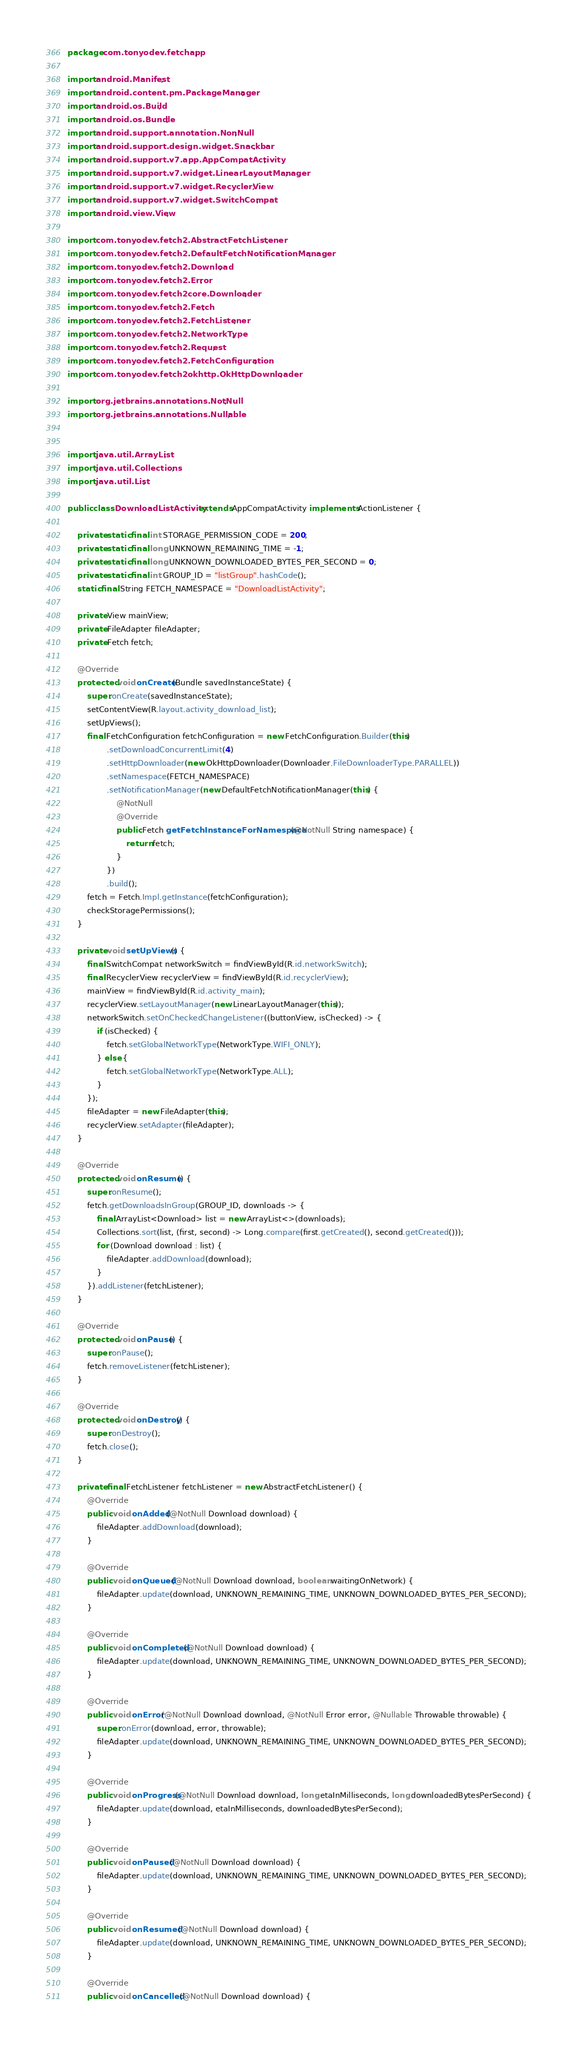Convert code to text. <code><loc_0><loc_0><loc_500><loc_500><_Java_>package com.tonyodev.fetchapp;

import android.Manifest;
import android.content.pm.PackageManager;
import android.os.Build;
import android.os.Bundle;
import android.support.annotation.NonNull;
import android.support.design.widget.Snackbar;
import android.support.v7.app.AppCompatActivity;
import android.support.v7.widget.LinearLayoutManager;
import android.support.v7.widget.RecyclerView;
import android.support.v7.widget.SwitchCompat;
import android.view.View;

import com.tonyodev.fetch2.AbstractFetchListener;
import com.tonyodev.fetch2.DefaultFetchNotificationManager;
import com.tonyodev.fetch2.Download;
import com.tonyodev.fetch2.Error;
import com.tonyodev.fetch2core.Downloader;
import com.tonyodev.fetch2.Fetch;
import com.tonyodev.fetch2.FetchListener;
import com.tonyodev.fetch2.NetworkType;
import com.tonyodev.fetch2.Request;
import com.tonyodev.fetch2.FetchConfiguration;
import com.tonyodev.fetch2okhttp.OkHttpDownloader;

import org.jetbrains.annotations.NotNull;
import org.jetbrains.annotations.Nullable;


import java.util.ArrayList;
import java.util.Collections;
import java.util.List;

public class DownloadListActivity extends AppCompatActivity implements ActionListener {

    private static final int STORAGE_PERMISSION_CODE = 200;
    private static final long UNKNOWN_REMAINING_TIME = -1;
    private static final long UNKNOWN_DOWNLOADED_BYTES_PER_SECOND = 0;
    private static final int GROUP_ID = "listGroup".hashCode();
    static final String FETCH_NAMESPACE = "DownloadListActivity";

    private View mainView;
    private FileAdapter fileAdapter;
    private Fetch fetch;

    @Override
    protected void onCreate(Bundle savedInstanceState) {
        super.onCreate(savedInstanceState);
        setContentView(R.layout.activity_download_list);
        setUpViews();
        final FetchConfiguration fetchConfiguration = new FetchConfiguration.Builder(this)
                .setDownloadConcurrentLimit(4)
                .setHttpDownloader(new OkHttpDownloader(Downloader.FileDownloaderType.PARALLEL))
                .setNamespace(FETCH_NAMESPACE)
                .setNotificationManager(new DefaultFetchNotificationManager(this) {
                    @NotNull
                    @Override
                    public Fetch getFetchInstanceForNamespace(@NotNull String namespace) {
                        return fetch;
                    }
                })
                .build();
        fetch = Fetch.Impl.getInstance(fetchConfiguration);
        checkStoragePermissions();
    }

    private void setUpViews() {
        final SwitchCompat networkSwitch = findViewById(R.id.networkSwitch);
        final RecyclerView recyclerView = findViewById(R.id.recyclerView);
        mainView = findViewById(R.id.activity_main);
        recyclerView.setLayoutManager(new LinearLayoutManager(this));
        networkSwitch.setOnCheckedChangeListener((buttonView, isChecked) -> {
            if (isChecked) {
                fetch.setGlobalNetworkType(NetworkType.WIFI_ONLY);
            } else {
                fetch.setGlobalNetworkType(NetworkType.ALL);
            }
        });
        fileAdapter = new FileAdapter(this);
        recyclerView.setAdapter(fileAdapter);
    }

    @Override
    protected void onResume() {
        super.onResume();
        fetch.getDownloadsInGroup(GROUP_ID, downloads -> {
            final ArrayList<Download> list = new ArrayList<>(downloads);
            Collections.sort(list, (first, second) -> Long.compare(first.getCreated(), second.getCreated()));
            for (Download download : list) {
                fileAdapter.addDownload(download);
            }
        }).addListener(fetchListener);
    }

    @Override
    protected void onPause() {
        super.onPause();
        fetch.removeListener(fetchListener);
    }

    @Override
    protected void onDestroy() {
        super.onDestroy();
        fetch.close();
    }

    private final FetchListener fetchListener = new AbstractFetchListener() {
        @Override
        public void onAdded(@NotNull Download download) {
            fileAdapter.addDownload(download);
        }

        @Override
        public void onQueued(@NotNull Download download, boolean waitingOnNetwork) {
            fileAdapter.update(download, UNKNOWN_REMAINING_TIME, UNKNOWN_DOWNLOADED_BYTES_PER_SECOND);
        }

        @Override
        public void onCompleted(@NotNull Download download) {
            fileAdapter.update(download, UNKNOWN_REMAINING_TIME, UNKNOWN_DOWNLOADED_BYTES_PER_SECOND);
        }

        @Override
        public void onError(@NotNull Download download, @NotNull Error error, @Nullable Throwable throwable) {
            super.onError(download, error, throwable);
            fileAdapter.update(download, UNKNOWN_REMAINING_TIME, UNKNOWN_DOWNLOADED_BYTES_PER_SECOND);
        }

        @Override
        public void onProgress(@NotNull Download download, long etaInMilliseconds, long downloadedBytesPerSecond) {
            fileAdapter.update(download, etaInMilliseconds, downloadedBytesPerSecond);
        }

        @Override
        public void onPaused(@NotNull Download download) {
            fileAdapter.update(download, UNKNOWN_REMAINING_TIME, UNKNOWN_DOWNLOADED_BYTES_PER_SECOND);
        }

        @Override
        public void onResumed(@NotNull Download download) {
            fileAdapter.update(download, UNKNOWN_REMAINING_TIME, UNKNOWN_DOWNLOADED_BYTES_PER_SECOND);
        }

        @Override
        public void onCancelled(@NotNull Download download) {</code> 